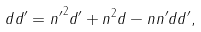<formula> <loc_0><loc_0><loc_500><loc_500>d d ^ { \prime } = { n ^ { \prime } } ^ { 2 } d ^ { \prime } + n ^ { 2 } d - n n ^ { \prime } d d ^ { \prime } ,</formula> 